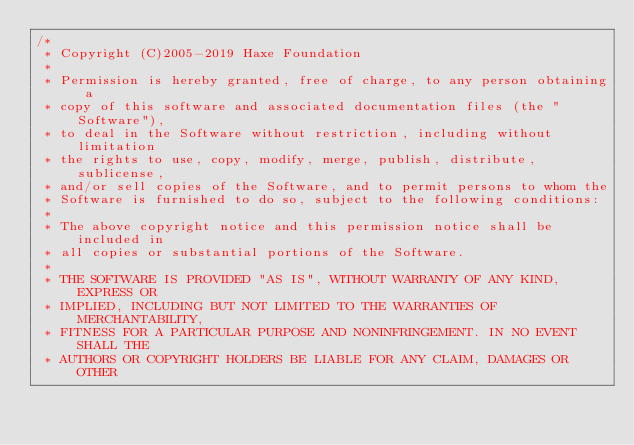<code> <loc_0><loc_0><loc_500><loc_500><_Haxe_>/*
 * Copyright (C)2005-2019 Haxe Foundation
 *
 * Permission is hereby granted, free of charge, to any person obtaining a
 * copy of this software and associated documentation files (the "Software"),
 * to deal in the Software without restriction, including without limitation
 * the rights to use, copy, modify, merge, publish, distribute, sublicense,
 * and/or sell copies of the Software, and to permit persons to whom the
 * Software is furnished to do so, subject to the following conditions:
 *
 * The above copyright notice and this permission notice shall be included in
 * all copies or substantial portions of the Software.
 *
 * THE SOFTWARE IS PROVIDED "AS IS", WITHOUT WARRANTY OF ANY KIND, EXPRESS OR
 * IMPLIED, INCLUDING BUT NOT LIMITED TO THE WARRANTIES OF MERCHANTABILITY,
 * FITNESS FOR A PARTICULAR PURPOSE AND NONINFRINGEMENT. IN NO EVENT SHALL THE
 * AUTHORS OR COPYRIGHT HOLDERS BE LIABLE FOR ANY CLAIM, DAMAGES OR OTHER</code> 